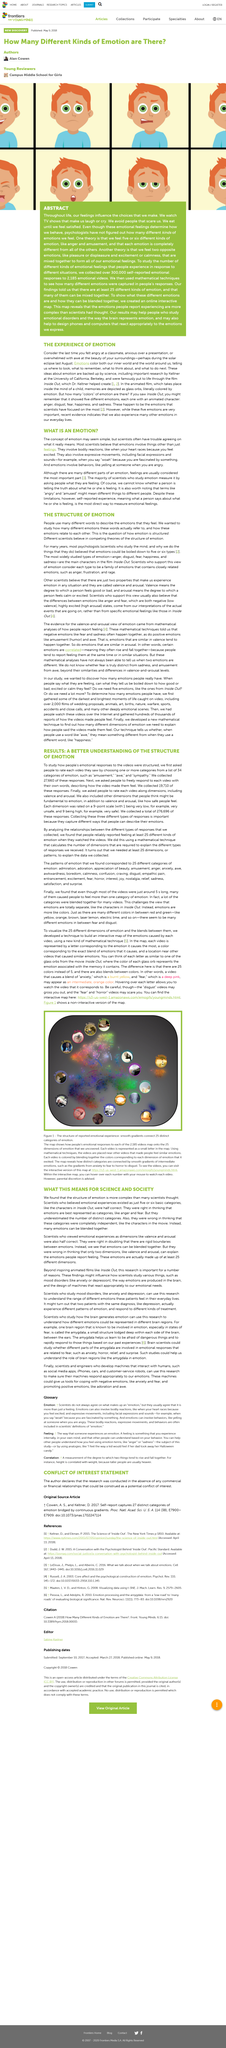Draw attention to some important aspects in this diagram. According to psychologists, emotions can be categorized into five or six types. Inside Out is the movie that is referenced when talking about emotions. Scientists are researching various moods, including anxiety and depression, for the purpose of understanding and treating disorders. It is estimated that at least 25 emotion dimensions exist. Anger, disgust, fear, happiness, and sadness are the most widely studied types of emotions. 